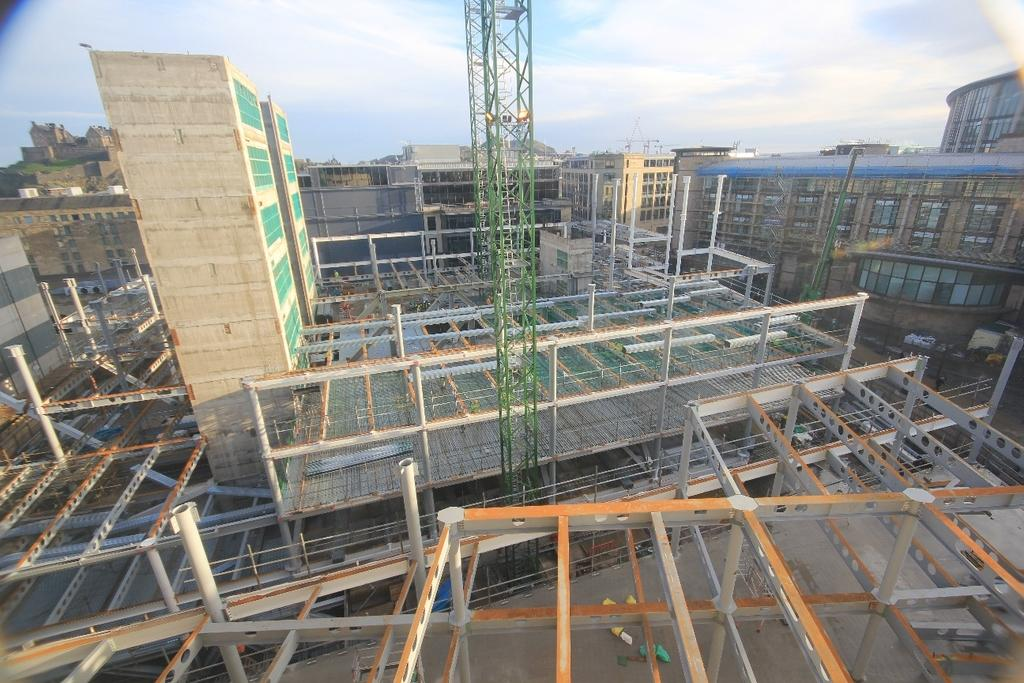What type of structures can be seen in the image? There are buildings in the image. What material are some of the objects made of? There are metal objects in the image. What stands out among the buildings? There is a tower in the image. What else can be seen in the image besides buildings and the tower? There are other objects in the image. What can be seen in the distance in the image? The sky is visible in the background of the image. Can you see any bubbles floating in the ocean in the image? There is no ocean or bubbles present in the image. 